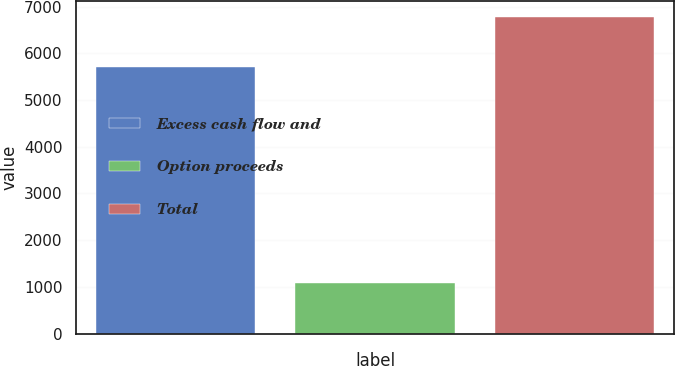Convert chart. <chart><loc_0><loc_0><loc_500><loc_500><bar_chart><fcel>Excess cash flow and<fcel>Option proceeds<fcel>Total<nl><fcel>5707<fcel>1074<fcel>6781<nl></chart> 